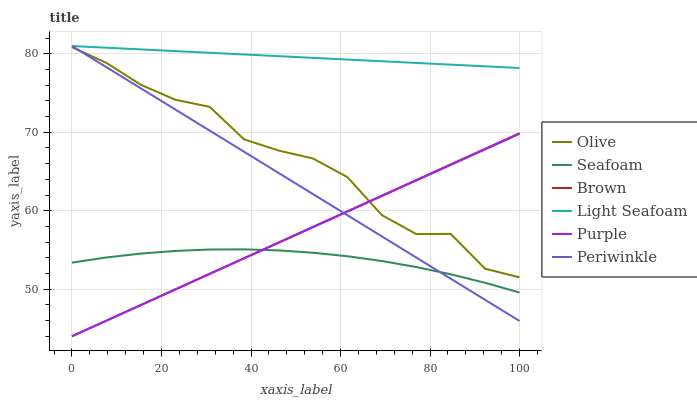Does Seafoam have the minimum area under the curve?
Answer yes or no. Yes. Does Light Seafoam have the maximum area under the curve?
Answer yes or no. Yes. Does Purple have the minimum area under the curve?
Answer yes or no. No. Does Purple have the maximum area under the curve?
Answer yes or no. No. Is Brown the smoothest?
Answer yes or no. Yes. Is Olive the roughest?
Answer yes or no. Yes. Is Purple the smoothest?
Answer yes or no. No. Is Purple the roughest?
Answer yes or no. No. Does Seafoam have the lowest value?
Answer yes or no. No. Does Purple have the highest value?
Answer yes or no. No. Is Olive less than Light Seafoam?
Answer yes or no. Yes. Is Light Seafoam greater than Purple?
Answer yes or no. Yes. Does Olive intersect Light Seafoam?
Answer yes or no. No. 